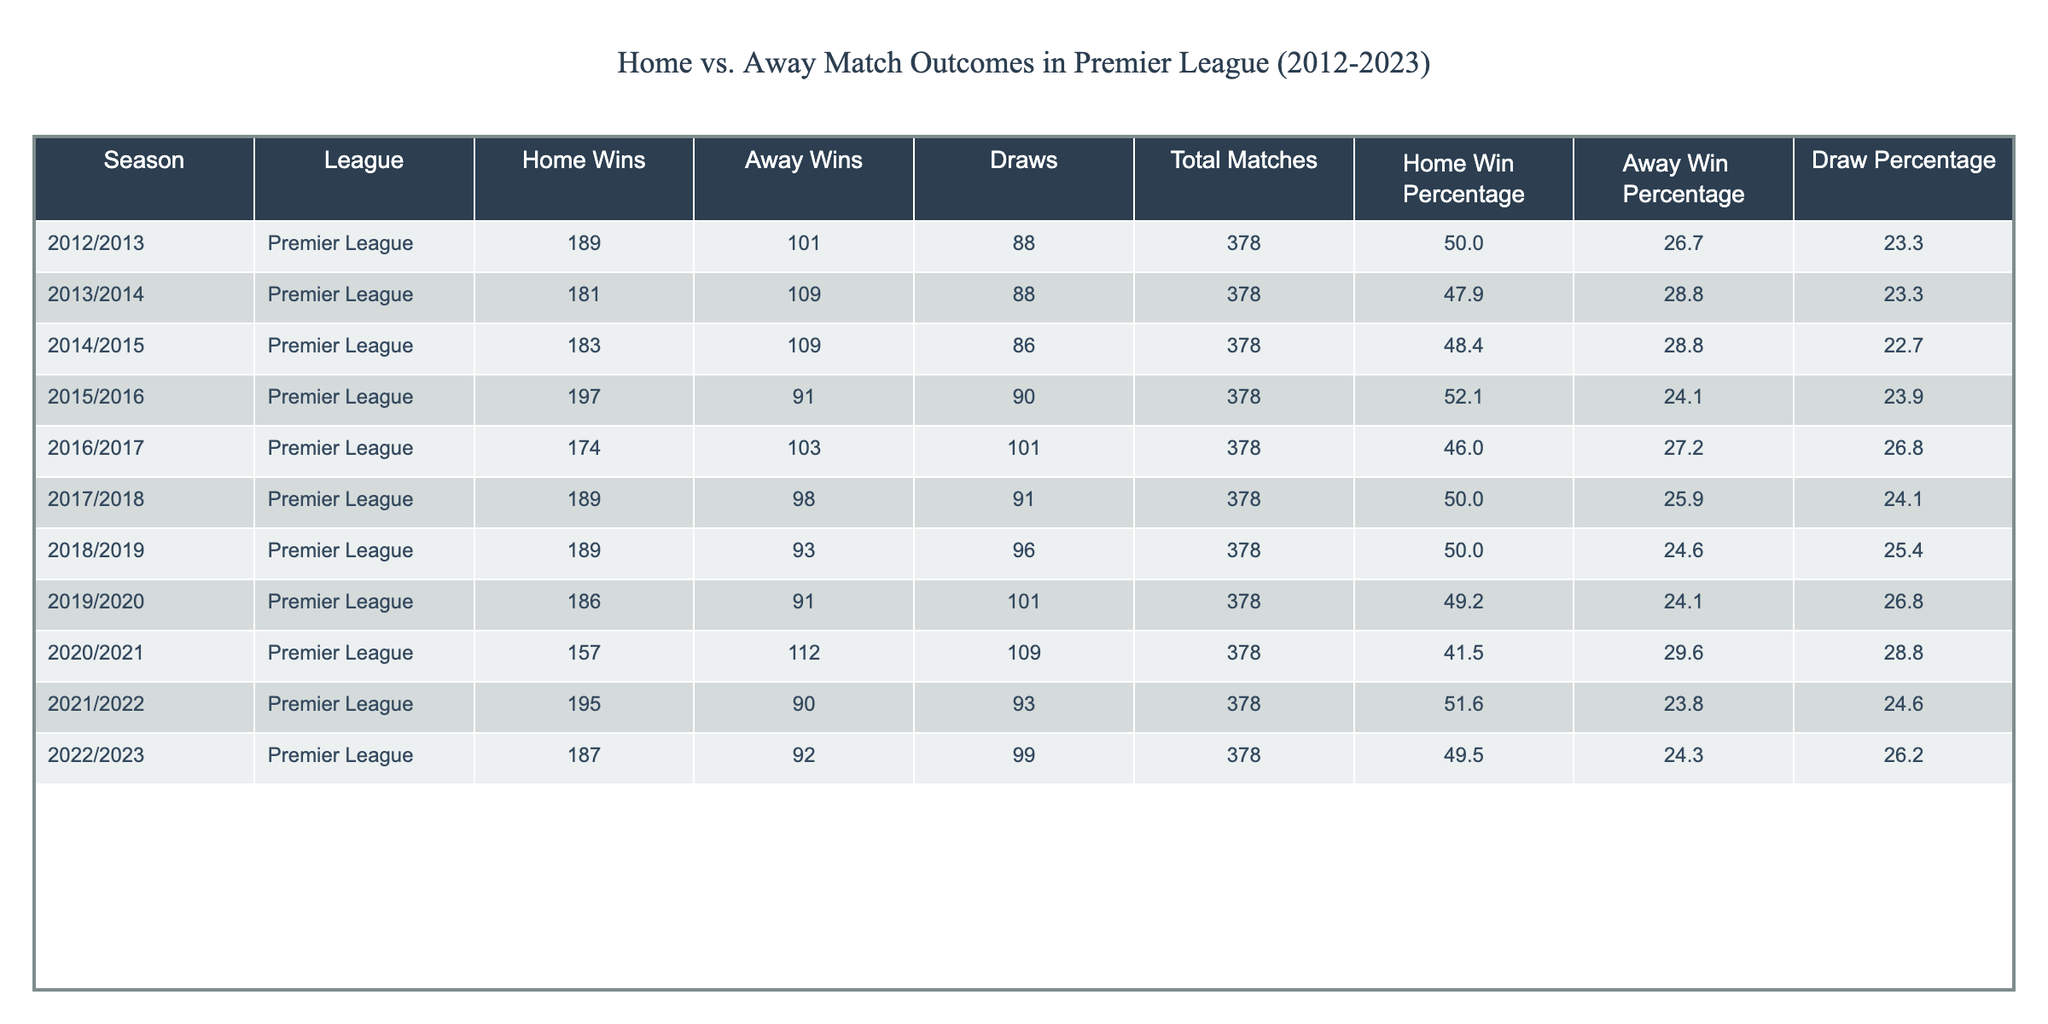What was the total number of matches played in the Premier League during the 2020/2021 season? The table shows that in the 2020/2021 season, the total number of matches played is explicitly provided in the "Total Matches" column, which states there were 378 matches.
Answer: 378 Which season had the highest percentage of home wins? By looking at the "Home Win Percentage" column, the highest value is 52.1%, which corresponds to the 2015/2016 season.
Answer: 2015/2016 How many more away wins than home wins were there in the 2013/2014 season? From the table, for the 2013/2014 season, there were 109 away wins and 181 home wins. To find out how many more away wins there were than home wins, subtract the number of home wins from away wins: 109 - 181 = -72 (indicating more home wins).
Answer: 72 (more home wins) In which season was the away win percentage the highest, and what was the percentage? To determine the highest away win percentage, we inspect the "Away Win Percentage" column. The highest value can be seen in the 2020/2021 season at 29.6%.
Answer: 2020/2021, 29.6% Was the average number of draws in home matches greater than or less than in away matches over all seasons? First, calculate the total draws across all seasons, which is 88 + 88 + 86 + 90 + 101 + 91 + 96 + 101 + 109 + 93 + 99 = 1,142. There were 11 seasons, so the average draws is 1,142 / 11 = 103.82. In home matches, draws do not directly apply, so comparing averages makes this average relative to home results, staying with draws overall. The average is less than home results continuously favoring home wins.
Answer: Less Did the number of draws in the last two seasons (2021/2022 and 2022/2023) exceed the number of home wins in 2014/2015? The last two seasons had the following draws: 93 (2021/2022) + 99 (2022/2023) = 192 draws. The home wins in 2014/2015 were 183. Since 192 is greater than 183, the total draws over the last two seasons exceed home wins in 2014/2015.
Answer: Yes 